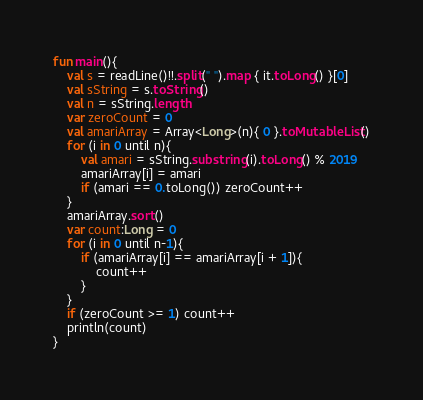<code> <loc_0><loc_0><loc_500><loc_500><_Kotlin_>fun main(){
    val s = readLine()!!.split(" ").map { it.toLong() }[0]
    val sString = s.toString()
    val n = sString.length
    var zeroCount = 0
    val amariArray = Array<Long>(n){ 0 }.toMutableList()
    for (i in 0 until n){
        val amari = sString.substring(i).toLong() % 2019
        amariArray[i] = amari
        if (amari == 0.toLong()) zeroCount++
    }
    amariArray.sort()
    var count:Long = 0
    for (i in 0 until n-1){
        if (amariArray[i] == amariArray[i + 1]){
            count++
        }
    }
    if (zeroCount >= 1) count++
    println(count)
}</code> 